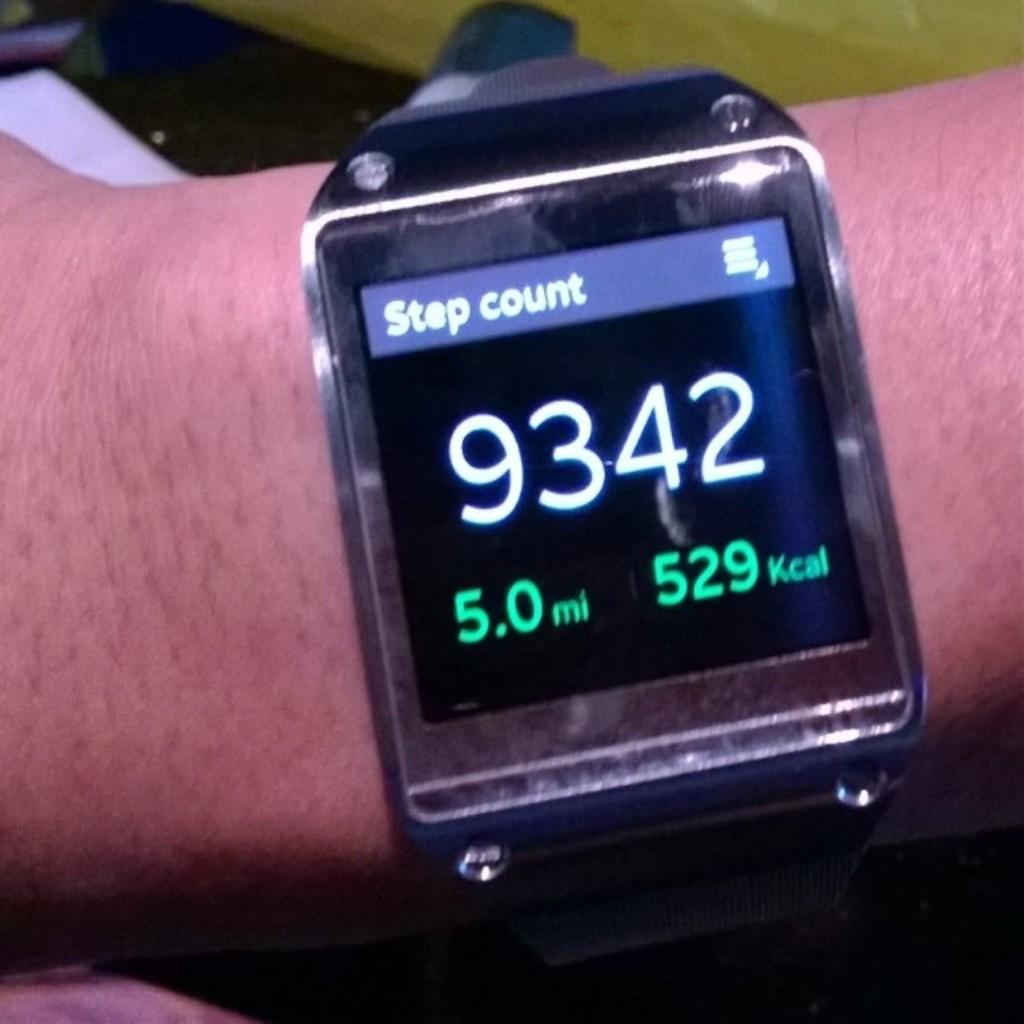Provide a one-sentence caption for the provided image. A smart watch on someone's arm is showing a step count of 9342. 